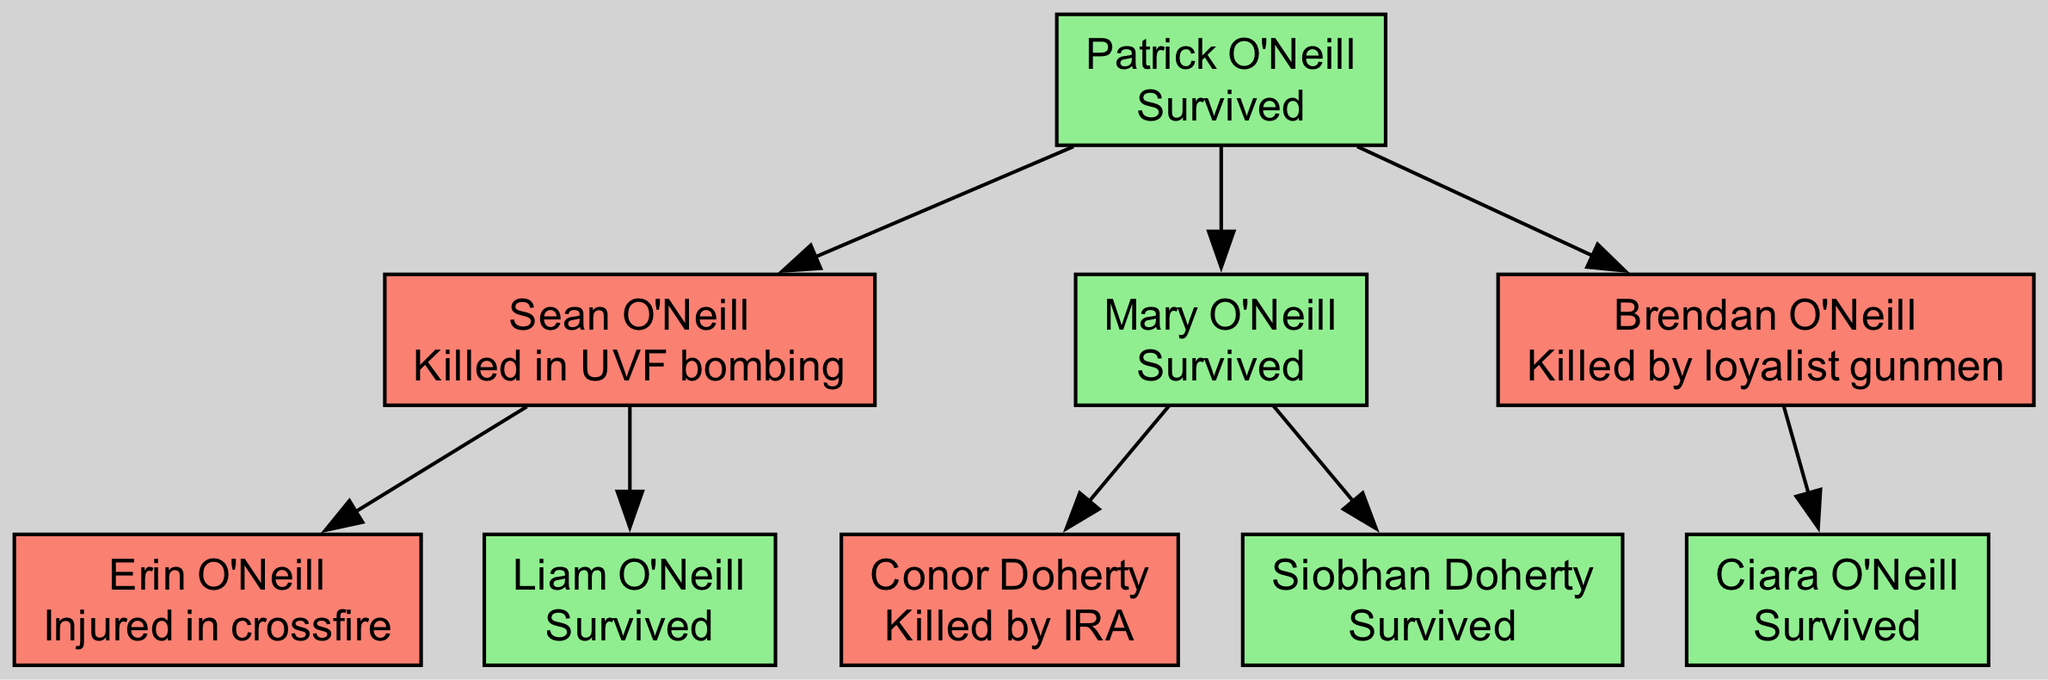What is the status of Patrick O'Neill? The diagram indicates that Patrick O'Neill is the root of the family tree, and his status is "Survived." This information is clearly labeled next to his name in the diagram.
Answer: Survived How many children does Patrick O'Neill have? By examining the diagram, it shows that Patrick O'Neill has three direct children: Sean O'Neill, Mary O'Neill, and Brendan O'Neill. This can be counted directly from the branches extending from his node.
Answer: 3 Who was killed by loyalist gunmen? Looking at the diagram, Brendan O'Neill is specifically mentioned with the status "Killed by loyalist gunmen." This is directly associated with his node in the visual representation.
Answer: Brendan O'Neill Which family member was injured in crossfire? The diagram shows that Erin O'Neill, a child of Sean O'Neill, is noted as "Injured in crossfire." This status appears under her node, allowing for easy identification.
Answer: Erin O'Neill What is the relationship between Siobhan Doherty and Patrick O'Neill? Siobhan Doherty is a child of Mary O'Neill, who is a child of Patrick O'Neill. Therefore, Siobhan is Patrick's grandchild, as detailed through the lineage displayed in the family tree.
Answer: Grandchild Who has the status "Killed by IRA"? The diagram explicitly states that Conor Doherty, a child of Mary O'Neill, has the status "Killed by IRA." This information is visible in the node corresponding to his name.
Answer: Conor Doherty Which member has no children? Reviewing the diagram, both Liam O'Neill and Siobhan Doherty do not have any listed children, making them the members without offspring in this family tree. However, since the question can have multiple acceptable answers, I will answer with one.
Answer: Liam O'Neill How many members have "Survived" as their status? The diagram reveals that Patrick O'Neill, Liam O'Neill, Mary O'Neill, Siobhan Doherty, and Ciara O'Neill all have the status "Survived." Counting these members gives a total of five individuals with that status.
Answer: 5 Which family members were affected by paramilitary violence? The diagram reflects that Sean O'Neill was killed in a UVF bombing, Conor Doherty was killed by IRA, and Brendan O'Neill was killed by loyalist gunmen, showing that these victims were impacted by paramilitary violence. Therefore, the answer lists these specific names.
Answer: Sean O'Neill, Conor Doherty, Brendan O'Neill 